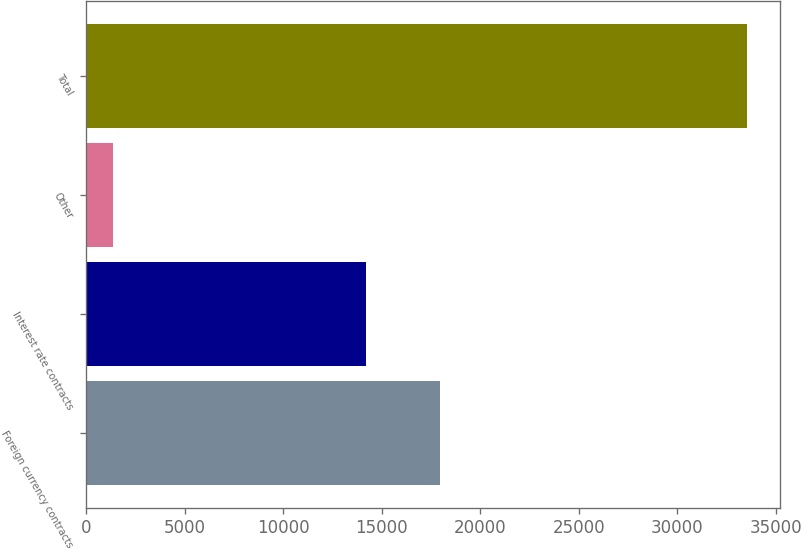<chart> <loc_0><loc_0><loc_500><loc_500><bar_chart><fcel>Foreign currency contracts<fcel>Interest rate contracts<fcel>Other<fcel>Total<nl><fcel>17960<fcel>14228<fcel>1340<fcel>33528<nl></chart> 